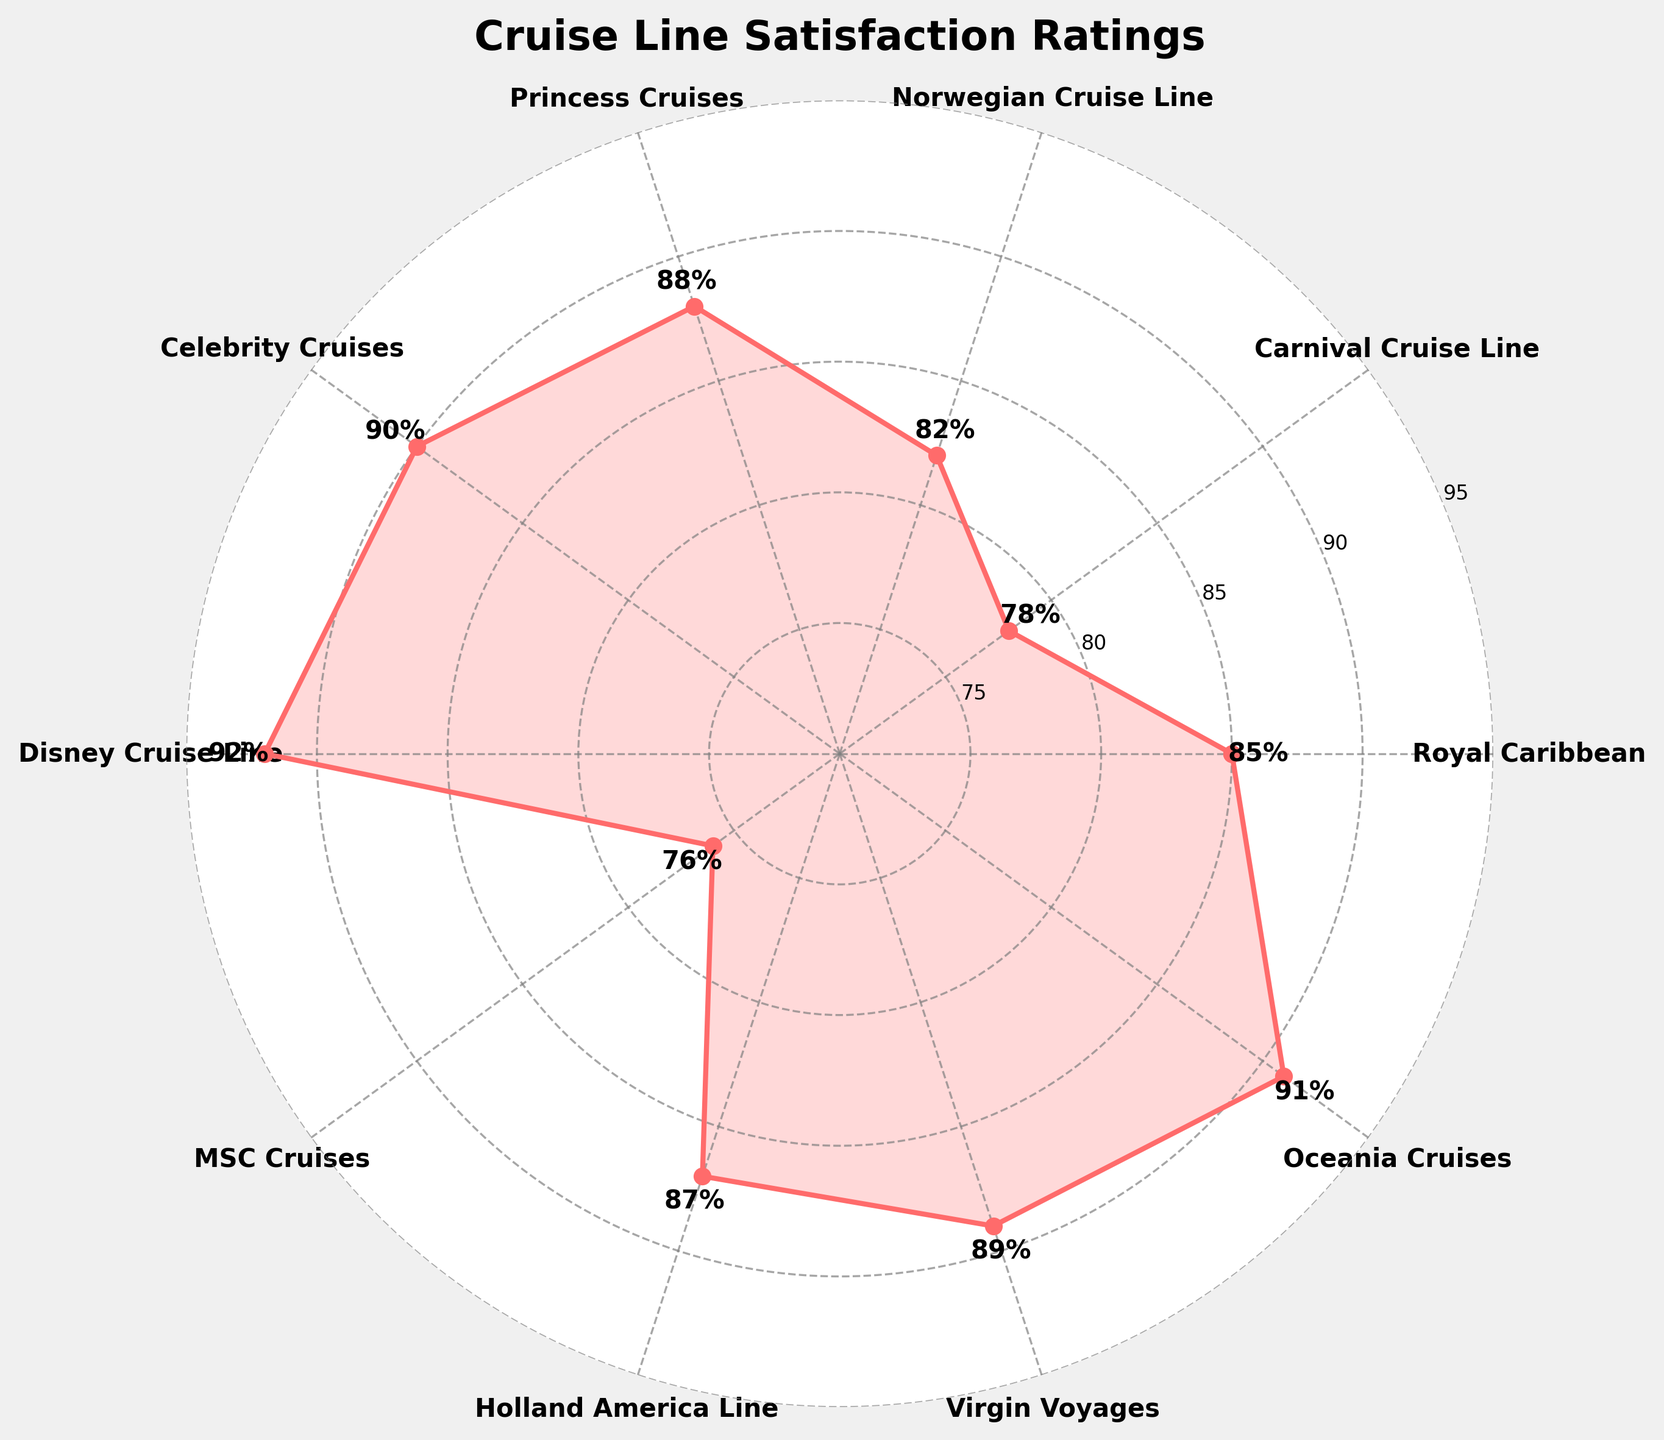What is the title of the figure? The title of the figure is centered at the top and clearly states the subject of the chart.
Answer: Cruise Line Satisfaction Ratings How many cruise lines are displayed in the figure? Count the number of distinct labels around the edge of the polar plot.
Answer: 10 Which cruise line has the highest satisfaction rating? Identify the cruise line whose satisfaction rating is at the maximum end of the chart.
Answer: Disney Cruise Line What is the satisfaction rating of Royal Caribbean? Find Royal Caribbean on the chart and look at the corresponding rating marked on the plot.
Answer: 85 Which cruise line has a lower satisfaction rating: MSC Cruises or Carnival Cruise Line? Compare the ratings marked for MSC Cruises and Carnival Cruise Line on the chart.
Answer: MSC Cruises What is the average satisfaction rating of all the cruise lines? Sum all the ratings and divide by the number of cruise lines (rounding to one decimal place). (85+78+82+88+90+92+76+87+89+91)/10 = 85.8
Answer: 85.8 What is the difference between the highest and lowest satisfaction ratings? Find the highest rating (Disney Cruise Line, 92) and the lowest rating (MSC Cruises, 76), then subtract the lowest from the highest. 92 - 76 = 16
Answer: 16 Which cruise line is positioned at the topmost part of the chart? Look for the cruise line labeled at the topmost position on the chart, which is usually at the 0-degree or 360-degree angle.
Answer: Royal Caribbean Which two cruise lines have the most similar satisfaction ratings? Look for the cruise lines whose satisfaction ratings are close together on the chart.
Answer: Celebrity Cruises and Oceania Cruises What color is used to fill the satisfaction rating area on the plot? Identify the dominant color used to shade the area representing satisfaction ratings.
Answer: Red 